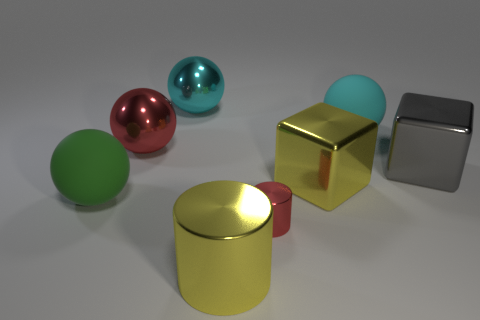There is a big object that is the same color as the big cylinder; what material is it?
Offer a terse response. Metal. Is the number of small red things that are to the right of the tiny cylinder less than the number of blocks left of the large gray metallic cube?
Ensure brevity in your answer.  Yes. Is the material of the small red object the same as the big gray cube?
Your answer should be compact. Yes. What is the size of the metal thing that is in front of the green matte ball and on the right side of the large metal cylinder?
Your answer should be compact. Small. The cyan metal object that is the same size as the red sphere is what shape?
Offer a very short reply. Sphere. The yellow object that is in front of the large matte thing that is to the left of the cyan ball that is on the right side of the yellow metal cylinder is made of what material?
Give a very brief answer. Metal. Does the large matte object that is to the right of the large shiny cylinder have the same shape as the big yellow metal object that is behind the big green matte ball?
Keep it short and to the point. No. What number of other things are made of the same material as the large red ball?
Your response must be concise. 5. Does the red object that is in front of the red ball have the same material as the red thing on the left side of the cyan shiny thing?
Your answer should be compact. Yes. There is a big cyan object that is made of the same material as the big green ball; what shape is it?
Make the answer very short. Sphere. 